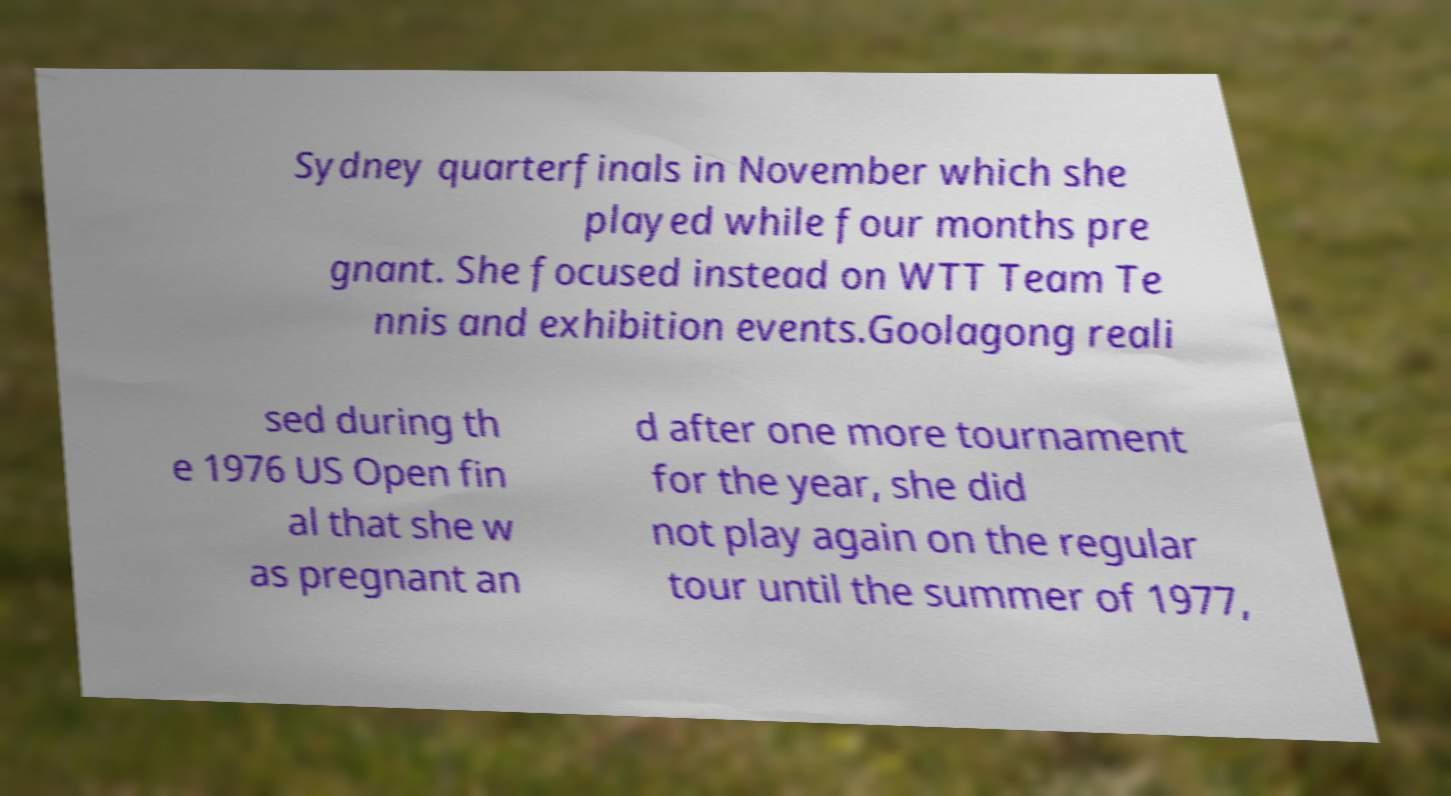Please identify and transcribe the text found in this image. Sydney quarterfinals in November which she played while four months pre gnant. She focused instead on WTT Team Te nnis and exhibition events.Goolagong reali sed during th e 1976 US Open fin al that she w as pregnant an d after one more tournament for the year, she did not play again on the regular tour until the summer of 1977, 